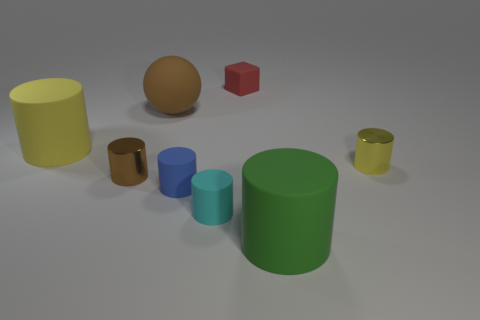Is the color of the metal cylinder that is to the right of the green rubber cylinder the same as the big rubber object that is in front of the brown cylinder?
Provide a succinct answer. No. The big green matte thing is what shape?
Provide a succinct answer. Cylinder. Are there more big spheres that are in front of the yellow matte cylinder than yellow matte objects?
Your answer should be compact. No. There is a yellow object that is in front of the yellow rubber cylinder; what shape is it?
Your response must be concise. Cylinder. What number of other things are the same shape as the cyan rubber thing?
Your response must be concise. 5. Is the material of the cylinder that is to the right of the green matte cylinder the same as the small blue cylinder?
Keep it short and to the point. No. Are there an equal number of green matte cylinders that are on the left side of the tiny cyan rubber cylinder and yellow objects that are behind the small red rubber block?
Your answer should be very brief. Yes. There is a yellow thing right of the big green rubber object; how big is it?
Your answer should be compact. Small. Is there a tiny blue object that has the same material as the big green cylinder?
Make the answer very short. Yes. There is a sphere that is right of the tiny brown shiny thing; is it the same color as the tiny cube?
Offer a very short reply. No. 